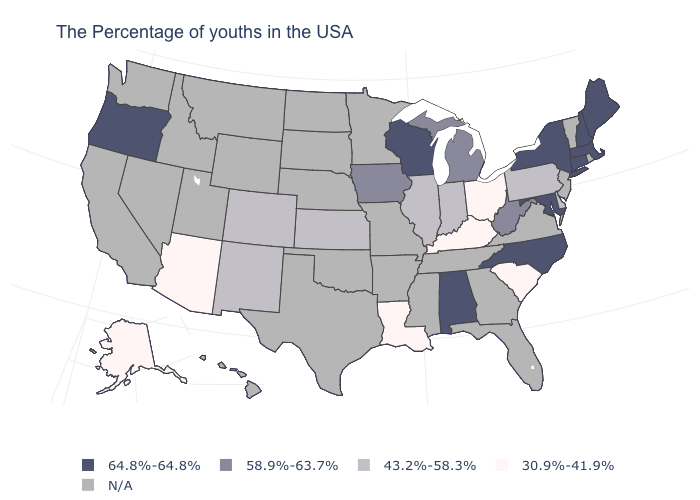Does Illinois have the lowest value in the USA?
Write a very short answer. No. Is the legend a continuous bar?
Answer briefly. No. Does the first symbol in the legend represent the smallest category?
Answer briefly. No. Name the states that have a value in the range 64.8%-64.8%?
Short answer required. Maine, Massachusetts, New Hampshire, Connecticut, New York, Maryland, North Carolina, Alabama, Wisconsin, Oregon. Name the states that have a value in the range 30.9%-41.9%?
Be succinct. South Carolina, Ohio, Kentucky, Louisiana, Arizona, Alaska. What is the lowest value in states that border Missouri?
Answer briefly. 30.9%-41.9%. What is the value of Utah?
Concise answer only. N/A. Name the states that have a value in the range 64.8%-64.8%?
Write a very short answer. Maine, Massachusetts, New Hampshire, Connecticut, New York, Maryland, North Carolina, Alabama, Wisconsin, Oregon. What is the value of North Dakota?
Short answer required. N/A. Does the map have missing data?
Keep it brief. Yes. What is the highest value in states that border Ohio?
Short answer required. 58.9%-63.7%. Name the states that have a value in the range 64.8%-64.8%?
Concise answer only. Maine, Massachusetts, New Hampshire, Connecticut, New York, Maryland, North Carolina, Alabama, Wisconsin, Oregon. Among the states that border Massachusetts , which have the lowest value?
Answer briefly. New Hampshire, Connecticut, New York. What is the lowest value in the USA?
Give a very brief answer. 30.9%-41.9%. Among the states that border Nevada , does Arizona have the lowest value?
Quick response, please. Yes. 